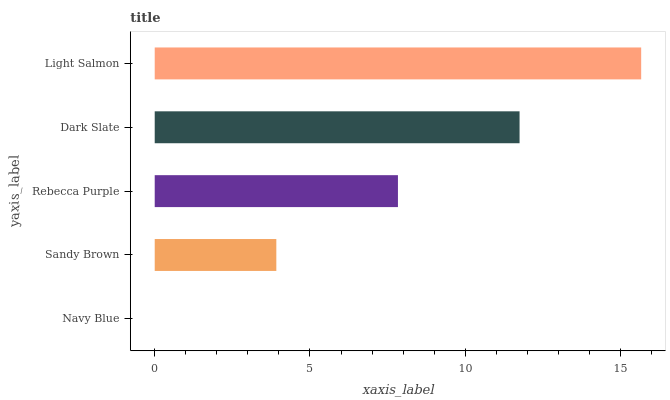Is Navy Blue the minimum?
Answer yes or no. Yes. Is Light Salmon the maximum?
Answer yes or no. Yes. Is Sandy Brown the minimum?
Answer yes or no. No. Is Sandy Brown the maximum?
Answer yes or no. No. Is Sandy Brown greater than Navy Blue?
Answer yes or no. Yes. Is Navy Blue less than Sandy Brown?
Answer yes or no. Yes. Is Navy Blue greater than Sandy Brown?
Answer yes or no. No. Is Sandy Brown less than Navy Blue?
Answer yes or no. No. Is Rebecca Purple the high median?
Answer yes or no. Yes. Is Rebecca Purple the low median?
Answer yes or no. Yes. Is Sandy Brown the high median?
Answer yes or no. No. Is Light Salmon the low median?
Answer yes or no. No. 